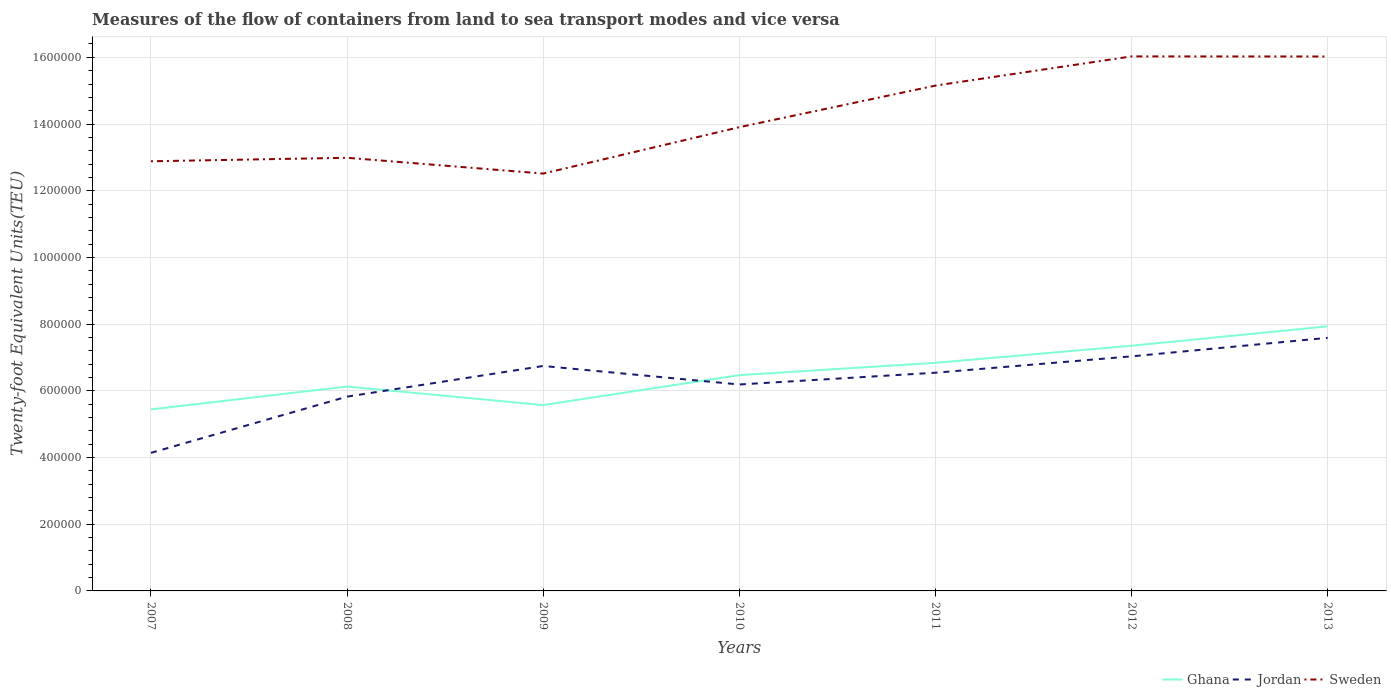Is the number of lines equal to the number of legend labels?
Provide a succinct answer. Yes. Across all years, what is the maximum container port traffic in Ghana?
Offer a very short reply. 5.44e+05. In which year was the container port traffic in Sweden maximum?
Provide a succinct answer. 2009. What is the total container port traffic in Jordan in the graph?
Your answer should be very brief. -4.91e+04. What is the difference between the highest and the second highest container port traffic in Ghana?
Make the answer very short. 2.49e+05. Is the container port traffic in Ghana strictly greater than the container port traffic in Jordan over the years?
Ensure brevity in your answer.  No. How many lines are there?
Give a very brief answer. 3. What is the difference between two consecutive major ticks on the Y-axis?
Your answer should be compact. 2.00e+05. Does the graph contain any zero values?
Offer a terse response. No. How are the legend labels stacked?
Ensure brevity in your answer.  Horizontal. What is the title of the graph?
Give a very brief answer. Measures of the flow of containers from land to sea transport modes and vice versa. Does "Isle of Man" appear as one of the legend labels in the graph?
Provide a short and direct response. No. What is the label or title of the Y-axis?
Ensure brevity in your answer.  Twenty-foot Equivalent Units(TEU). What is the Twenty-foot Equivalent Units(TEU) of Ghana in 2007?
Your answer should be compact. 5.44e+05. What is the Twenty-foot Equivalent Units(TEU) of Jordan in 2007?
Keep it short and to the point. 4.14e+05. What is the Twenty-foot Equivalent Units(TEU) of Sweden in 2007?
Make the answer very short. 1.29e+06. What is the Twenty-foot Equivalent Units(TEU) of Ghana in 2008?
Offer a very short reply. 6.13e+05. What is the Twenty-foot Equivalent Units(TEU) of Jordan in 2008?
Keep it short and to the point. 5.83e+05. What is the Twenty-foot Equivalent Units(TEU) in Sweden in 2008?
Your answer should be compact. 1.30e+06. What is the Twenty-foot Equivalent Units(TEU) of Ghana in 2009?
Provide a short and direct response. 5.57e+05. What is the Twenty-foot Equivalent Units(TEU) in Jordan in 2009?
Make the answer very short. 6.75e+05. What is the Twenty-foot Equivalent Units(TEU) in Sweden in 2009?
Your response must be concise. 1.25e+06. What is the Twenty-foot Equivalent Units(TEU) of Ghana in 2010?
Offer a very short reply. 6.47e+05. What is the Twenty-foot Equivalent Units(TEU) of Jordan in 2010?
Offer a very short reply. 6.19e+05. What is the Twenty-foot Equivalent Units(TEU) of Sweden in 2010?
Provide a succinct answer. 1.39e+06. What is the Twenty-foot Equivalent Units(TEU) in Ghana in 2011?
Offer a terse response. 6.84e+05. What is the Twenty-foot Equivalent Units(TEU) in Jordan in 2011?
Ensure brevity in your answer.  6.54e+05. What is the Twenty-foot Equivalent Units(TEU) in Sweden in 2011?
Offer a terse response. 1.52e+06. What is the Twenty-foot Equivalent Units(TEU) of Ghana in 2012?
Offer a very short reply. 7.35e+05. What is the Twenty-foot Equivalent Units(TEU) of Jordan in 2012?
Your answer should be compact. 7.03e+05. What is the Twenty-foot Equivalent Units(TEU) of Sweden in 2012?
Your answer should be compact. 1.60e+06. What is the Twenty-foot Equivalent Units(TEU) in Ghana in 2013?
Offer a very short reply. 7.93e+05. What is the Twenty-foot Equivalent Units(TEU) in Jordan in 2013?
Offer a terse response. 7.59e+05. What is the Twenty-foot Equivalent Units(TEU) of Sweden in 2013?
Offer a terse response. 1.60e+06. Across all years, what is the maximum Twenty-foot Equivalent Units(TEU) of Ghana?
Your response must be concise. 7.93e+05. Across all years, what is the maximum Twenty-foot Equivalent Units(TEU) in Jordan?
Your answer should be very brief. 7.59e+05. Across all years, what is the maximum Twenty-foot Equivalent Units(TEU) in Sweden?
Give a very brief answer. 1.60e+06. Across all years, what is the minimum Twenty-foot Equivalent Units(TEU) in Ghana?
Offer a terse response. 5.44e+05. Across all years, what is the minimum Twenty-foot Equivalent Units(TEU) of Jordan?
Offer a terse response. 4.14e+05. Across all years, what is the minimum Twenty-foot Equivalent Units(TEU) of Sweden?
Give a very brief answer. 1.25e+06. What is the total Twenty-foot Equivalent Units(TEU) in Ghana in the graph?
Provide a succinct answer. 4.57e+06. What is the total Twenty-foot Equivalent Units(TEU) in Jordan in the graph?
Keep it short and to the point. 4.41e+06. What is the total Twenty-foot Equivalent Units(TEU) of Sweden in the graph?
Offer a terse response. 9.95e+06. What is the difference between the Twenty-foot Equivalent Units(TEU) of Ghana in 2007 and that in 2008?
Your answer should be compact. -6.86e+04. What is the difference between the Twenty-foot Equivalent Units(TEU) of Jordan in 2007 and that in 2008?
Your answer should be very brief. -1.69e+05. What is the difference between the Twenty-foot Equivalent Units(TEU) of Sweden in 2007 and that in 2008?
Ensure brevity in your answer.  -1.05e+04. What is the difference between the Twenty-foot Equivalent Units(TEU) in Ghana in 2007 and that in 2009?
Keep it short and to the point. -1.30e+04. What is the difference between the Twenty-foot Equivalent Units(TEU) in Jordan in 2007 and that in 2009?
Offer a very short reply. -2.61e+05. What is the difference between the Twenty-foot Equivalent Units(TEU) of Sweden in 2007 and that in 2009?
Offer a terse response. 3.69e+04. What is the difference between the Twenty-foot Equivalent Units(TEU) of Ghana in 2007 and that in 2010?
Your response must be concise. -1.03e+05. What is the difference between the Twenty-foot Equivalent Units(TEU) in Jordan in 2007 and that in 2010?
Keep it short and to the point. -2.05e+05. What is the difference between the Twenty-foot Equivalent Units(TEU) of Sweden in 2007 and that in 2010?
Offer a terse response. -1.02e+05. What is the difference between the Twenty-foot Equivalent Units(TEU) in Ghana in 2007 and that in 2011?
Give a very brief answer. -1.40e+05. What is the difference between the Twenty-foot Equivalent Units(TEU) of Jordan in 2007 and that in 2011?
Make the answer very short. -2.40e+05. What is the difference between the Twenty-foot Equivalent Units(TEU) in Sweden in 2007 and that in 2011?
Provide a short and direct response. -2.27e+05. What is the difference between the Twenty-foot Equivalent Units(TEU) of Ghana in 2007 and that in 2012?
Provide a short and direct response. -1.91e+05. What is the difference between the Twenty-foot Equivalent Units(TEU) of Jordan in 2007 and that in 2012?
Ensure brevity in your answer.  -2.89e+05. What is the difference between the Twenty-foot Equivalent Units(TEU) of Sweden in 2007 and that in 2012?
Ensure brevity in your answer.  -3.14e+05. What is the difference between the Twenty-foot Equivalent Units(TEU) in Ghana in 2007 and that in 2013?
Provide a succinct answer. -2.49e+05. What is the difference between the Twenty-foot Equivalent Units(TEU) in Jordan in 2007 and that in 2013?
Provide a short and direct response. -3.45e+05. What is the difference between the Twenty-foot Equivalent Units(TEU) of Sweden in 2007 and that in 2013?
Your answer should be very brief. -3.14e+05. What is the difference between the Twenty-foot Equivalent Units(TEU) in Ghana in 2008 and that in 2009?
Your answer should be very brief. 5.55e+04. What is the difference between the Twenty-foot Equivalent Units(TEU) in Jordan in 2008 and that in 2009?
Ensure brevity in your answer.  -9.20e+04. What is the difference between the Twenty-foot Equivalent Units(TEU) in Sweden in 2008 and that in 2009?
Your answer should be very brief. 4.74e+04. What is the difference between the Twenty-foot Equivalent Units(TEU) of Ghana in 2008 and that in 2010?
Offer a terse response. -3.42e+04. What is the difference between the Twenty-foot Equivalent Units(TEU) in Jordan in 2008 and that in 2010?
Your answer should be compact. -3.65e+04. What is the difference between the Twenty-foot Equivalent Units(TEU) in Sweden in 2008 and that in 2010?
Ensure brevity in your answer.  -9.17e+04. What is the difference between the Twenty-foot Equivalent Units(TEU) in Ghana in 2008 and that in 2011?
Offer a terse response. -7.11e+04. What is the difference between the Twenty-foot Equivalent Units(TEU) of Jordan in 2008 and that in 2011?
Your answer should be compact. -7.18e+04. What is the difference between the Twenty-foot Equivalent Units(TEU) of Sweden in 2008 and that in 2011?
Offer a very short reply. -2.16e+05. What is the difference between the Twenty-foot Equivalent Units(TEU) of Ghana in 2008 and that in 2012?
Your answer should be compact. -1.22e+05. What is the difference between the Twenty-foot Equivalent Units(TEU) in Jordan in 2008 and that in 2012?
Keep it short and to the point. -1.21e+05. What is the difference between the Twenty-foot Equivalent Units(TEU) of Sweden in 2008 and that in 2012?
Give a very brief answer. -3.04e+05. What is the difference between the Twenty-foot Equivalent Units(TEU) in Ghana in 2008 and that in 2013?
Keep it short and to the point. -1.80e+05. What is the difference between the Twenty-foot Equivalent Units(TEU) in Jordan in 2008 and that in 2013?
Keep it short and to the point. -1.76e+05. What is the difference between the Twenty-foot Equivalent Units(TEU) of Sweden in 2008 and that in 2013?
Offer a very short reply. -3.04e+05. What is the difference between the Twenty-foot Equivalent Units(TEU) of Ghana in 2009 and that in 2010?
Offer a very short reply. -8.97e+04. What is the difference between the Twenty-foot Equivalent Units(TEU) of Jordan in 2009 and that in 2010?
Offer a terse response. 5.55e+04. What is the difference between the Twenty-foot Equivalent Units(TEU) of Sweden in 2009 and that in 2010?
Your answer should be compact. -1.39e+05. What is the difference between the Twenty-foot Equivalent Units(TEU) in Ghana in 2009 and that in 2011?
Provide a succinct answer. -1.27e+05. What is the difference between the Twenty-foot Equivalent Units(TEU) of Jordan in 2009 and that in 2011?
Your answer should be compact. 2.02e+04. What is the difference between the Twenty-foot Equivalent Units(TEU) of Sweden in 2009 and that in 2011?
Provide a succinct answer. -2.64e+05. What is the difference between the Twenty-foot Equivalent Units(TEU) of Ghana in 2009 and that in 2012?
Ensure brevity in your answer.  -1.78e+05. What is the difference between the Twenty-foot Equivalent Units(TEU) of Jordan in 2009 and that in 2012?
Offer a terse response. -2.88e+04. What is the difference between the Twenty-foot Equivalent Units(TEU) in Sweden in 2009 and that in 2012?
Offer a very short reply. -3.51e+05. What is the difference between the Twenty-foot Equivalent Units(TEU) of Ghana in 2009 and that in 2013?
Make the answer very short. -2.36e+05. What is the difference between the Twenty-foot Equivalent Units(TEU) in Jordan in 2009 and that in 2013?
Make the answer very short. -8.44e+04. What is the difference between the Twenty-foot Equivalent Units(TEU) in Sweden in 2009 and that in 2013?
Your response must be concise. -3.51e+05. What is the difference between the Twenty-foot Equivalent Units(TEU) of Ghana in 2010 and that in 2011?
Offer a terse response. -3.69e+04. What is the difference between the Twenty-foot Equivalent Units(TEU) in Jordan in 2010 and that in 2011?
Your answer should be very brief. -3.53e+04. What is the difference between the Twenty-foot Equivalent Units(TEU) of Sweden in 2010 and that in 2011?
Your answer should be very brief. -1.25e+05. What is the difference between the Twenty-foot Equivalent Units(TEU) in Ghana in 2010 and that in 2012?
Keep it short and to the point. -8.82e+04. What is the difference between the Twenty-foot Equivalent Units(TEU) in Jordan in 2010 and that in 2012?
Provide a succinct answer. -8.44e+04. What is the difference between the Twenty-foot Equivalent Units(TEU) in Sweden in 2010 and that in 2012?
Your answer should be very brief. -2.12e+05. What is the difference between the Twenty-foot Equivalent Units(TEU) in Ghana in 2010 and that in 2013?
Your response must be concise. -1.46e+05. What is the difference between the Twenty-foot Equivalent Units(TEU) of Jordan in 2010 and that in 2013?
Provide a succinct answer. -1.40e+05. What is the difference between the Twenty-foot Equivalent Units(TEU) of Sweden in 2010 and that in 2013?
Offer a terse response. -2.12e+05. What is the difference between the Twenty-foot Equivalent Units(TEU) in Ghana in 2011 and that in 2012?
Keep it short and to the point. -5.13e+04. What is the difference between the Twenty-foot Equivalent Units(TEU) in Jordan in 2011 and that in 2012?
Your answer should be very brief. -4.91e+04. What is the difference between the Twenty-foot Equivalent Units(TEU) of Sweden in 2011 and that in 2012?
Make the answer very short. -8.76e+04. What is the difference between the Twenty-foot Equivalent Units(TEU) in Ghana in 2011 and that in 2013?
Ensure brevity in your answer.  -1.09e+05. What is the difference between the Twenty-foot Equivalent Units(TEU) of Jordan in 2011 and that in 2013?
Offer a very short reply. -1.05e+05. What is the difference between the Twenty-foot Equivalent Units(TEU) in Sweden in 2011 and that in 2013?
Keep it short and to the point. -8.73e+04. What is the difference between the Twenty-foot Equivalent Units(TEU) of Ghana in 2012 and that in 2013?
Give a very brief answer. -5.81e+04. What is the difference between the Twenty-foot Equivalent Units(TEU) in Jordan in 2012 and that in 2013?
Your answer should be compact. -5.56e+04. What is the difference between the Twenty-foot Equivalent Units(TEU) of Sweden in 2012 and that in 2013?
Offer a very short reply. 302.98. What is the difference between the Twenty-foot Equivalent Units(TEU) in Ghana in 2007 and the Twenty-foot Equivalent Units(TEU) in Jordan in 2008?
Your answer should be compact. -3.82e+04. What is the difference between the Twenty-foot Equivalent Units(TEU) in Ghana in 2007 and the Twenty-foot Equivalent Units(TEU) in Sweden in 2008?
Offer a very short reply. -7.54e+05. What is the difference between the Twenty-foot Equivalent Units(TEU) in Jordan in 2007 and the Twenty-foot Equivalent Units(TEU) in Sweden in 2008?
Ensure brevity in your answer.  -8.85e+05. What is the difference between the Twenty-foot Equivalent Units(TEU) in Ghana in 2007 and the Twenty-foot Equivalent Units(TEU) in Jordan in 2009?
Make the answer very short. -1.30e+05. What is the difference between the Twenty-foot Equivalent Units(TEU) in Ghana in 2007 and the Twenty-foot Equivalent Units(TEU) in Sweden in 2009?
Offer a terse response. -7.07e+05. What is the difference between the Twenty-foot Equivalent Units(TEU) of Jordan in 2007 and the Twenty-foot Equivalent Units(TEU) of Sweden in 2009?
Offer a very short reply. -8.37e+05. What is the difference between the Twenty-foot Equivalent Units(TEU) in Ghana in 2007 and the Twenty-foot Equivalent Units(TEU) in Jordan in 2010?
Give a very brief answer. -7.47e+04. What is the difference between the Twenty-foot Equivalent Units(TEU) in Ghana in 2007 and the Twenty-foot Equivalent Units(TEU) in Sweden in 2010?
Your answer should be very brief. -8.46e+05. What is the difference between the Twenty-foot Equivalent Units(TEU) in Jordan in 2007 and the Twenty-foot Equivalent Units(TEU) in Sweden in 2010?
Your answer should be compact. -9.77e+05. What is the difference between the Twenty-foot Equivalent Units(TEU) in Ghana in 2007 and the Twenty-foot Equivalent Units(TEU) in Jordan in 2011?
Ensure brevity in your answer.  -1.10e+05. What is the difference between the Twenty-foot Equivalent Units(TEU) in Ghana in 2007 and the Twenty-foot Equivalent Units(TEU) in Sweden in 2011?
Offer a terse response. -9.71e+05. What is the difference between the Twenty-foot Equivalent Units(TEU) of Jordan in 2007 and the Twenty-foot Equivalent Units(TEU) of Sweden in 2011?
Your answer should be very brief. -1.10e+06. What is the difference between the Twenty-foot Equivalent Units(TEU) of Ghana in 2007 and the Twenty-foot Equivalent Units(TEU) of Jordan in 2012?
Your answer should be compact. -1.59e+05. What is the difference between the Twenty-foot Equivalent Units(TEU) of Ghana in 2007 and the Twenty-foot Equivalent Units(TEU) of Sweden in 2012?
Your answer should be very brief. -1.06e+06. What is the difference between the Twenty-foot Equivalent Units(TEU) of Jordan in 2007 and the Twenty-foot Equivalent Units(TEU) of Sweden in 2012?
Provide a succinct answer. -1.19e+06. What is the difference between the Twenty-foot Equivalent Units(TEU) in Ghana in 2007 and the Twenty-foot Equivalent Units(TEU) in Jordan in 2013?
Keep it short and to the point. -2.15e+05. What is the difference between the Twenty-foot Equivalent Units(TEU) in Ghana in 2007 and the Twenty-foot Equivalent Units(TEU) in Sweden in 2013?
Provide a short and direct response. -1.06e+06. What is the difference between the Twenty-foot Equivalent Units(TEU) of Jordan in 2007 and the Twenty-foot Equivalent Units(TEU) of Sweden in 2013?
Offer a very short reply. -1.19e+06. What is the difference between the Twenty-foot Equivalent Units(TEU) in Ghana in 2008 and the Twenty-foot Equivalent Units(TEU) in Jordan in 2009?
Make the answer very short. -6.17e+04. What is the difference between the Twenty-foot Equivalent Units(TEU) in Ghana in 2008 and the Twenty-foot Equivalent Units(TEU) in Sweden in 2009?
Offer a terse response. -6.39e+05. What is the difference between the Twenty-foot Equivalent Units(TEU) of Jordan in 2008 and the Twenty-foot Equivalent Units(TEU) of Sweden in 2009?
Offer a terse response. -6.69e+05. What is the difference between the Twenty-foot Equivalent Units(TEU) of Ghana in 2008 and the Twenty-foot Equivalent Units(TEU) of Jordan in 2010?
Ensure brevity in your answer.  -6152.83. What is the difference between the Twenty-foot Equivalent Units(TEU) in Ghana in 2008 and the Twenty-foot Equivalent Units(TEU) in Sweden in 2010?
Offer a terse response. -7.78e+05. What is the difference between the Twenty-foot Equivalent Units(TEU) of Jordan in 2008 and the Twenty-foot Equivalent Units(TEU) of Sweden in 2010?
Ensure brevity in your answer.  -8.08e+05. What is the difference between the Twenty-foot Equivalent Units(TEU) of Ghana in 2008 and the Twenty-foot Equivalent Units(TEU) of Jordan in 2011?
Your answer should be compact. -4.14e+04. What is the difference between the Twenty-foot Equivalent Units(TEU) of Ghana in 2008 and the Twenty-foot Equivalent Units(TEU) of Sweden in 2011?
Provide a succinct answer. -9.02e+05. What is the difference between the Twenty-foot Equivalent Units(TEU) in Jordan in 2008 and the Twenty-foot Equivalent Units(TEU) in Sweden in 2011?
Ensure brevity in your answer.  -9.33e+05. What is the difference between the Twenty-foot Equivalent Units(TEU) in Ghana in 2008 and the Twenty-foot Equivalent Units(TEU) in Jordan in 2012?
Your response must be concise. -9.05e+04. What is the difference between the Twenty-foot Equivalent Units(TEU) in Ghana in 2008 and the Twenty-foot Equivalent Units(TEU) in Sweden in 2012?
Provide a succinct answer. -9.90e+05. What is the difference between the Twenty-foot Equivalent Units(TEU) in Jordan in 2008 and the Twenty-foot Equivalent Units(TEU) in Sweden in 2012?
Offer a very short reply. -1.02e+06. What is the difference between the Twenty-foot Equivalent Units(TEU) in Ghana in 2008 and the Twenty-foot Equivalent Units(TEU) in Jordan in 2013?
Give a very brief answer. -1.46e+05. What is the difference between the Twenty-foot Equivalent Units(TEU) in Ghana in 2008 and the Twenty-foot Equivalent Units(TEU) in Sweden in 2013?
Make the answer very short. -9.90e+05. What is the difference between the Twenty-foot Equivalent Units(TEU) of Jordan in 2008 and the Twenty-foot Equivalent Units(TEU) of Sweden in 2013?
Give a very brief answer. -1.02e+06. What is the difference between the Twenty-foot Equivalent Units(TEU) of Ghana in 2009 and the Twenty-foot Equivalent Units(TEU) of Jordan in 2010?
Give a very brief answer. -6.17e+04. What is the difference between the Twenty-foot Equivalent Units(TEU) of Ghana in 2009 and the Twenty-foot Equivalent Units(TEU) of Sweden in 2010?
Give a very brief answer. -8.33e+05. What is the difference between the Twenty-foot Equivalent Units(TEU) in Jordan in 2009 and the Twenty-foot Equivalent Units(TEU) in Sweden in 2010?
Provide a succinct answer. -7.16e+05. What is the difference between the Twenty-foot Equivalent Units(TEU) in Ghana in 2009 and the Twenty-foot Equivalent Units(TEU) in Jordan in 2011?
Provide a short and direct response. -9.70e+04. What is the difference between the Twenty-foot Equivalent Units(TEU) of Ghana in 2009 and the Twenty-foot Equivalent Units(TEU) of Sweden in 2011?
Provide a succinct answer. -9.58e+05. What is the difference between the Twenty-foot Equivalent Units(TEU) of Jordan in 2009 and the Twenty-foot Equivalent Units(TEU) of Sweden in 2011?
Ensure brevity in your answer.  -8.41e+05. What is the difference between the Twenty-foot Equivalent Units(TEU) of Ghana in 2009 and the Twenty-foot Equivalent Units(TEU) of Jordan in 2012?
Give a very brief answer. -1.46e+05. What is the difference between the Twenty-foot Equivalent Units(TEU) in Ghana in 2009 and the Twenty-foot Equivalent Units(TEU) in Sweden in 2012?
Provide a short and direct response. -1.05e+06. What is the difference between the Twenty-foot Equivalent Units(TEU) of Jordan in 2009 and the Twenty-foot Equivalent Units(TEU) of Sweden in 2012?
Offer a very short reply. -9.28e+05. What is the difference between the Twenty-foot Equivalent Units(TEU) in Ghana in 2009 and the Twenty-foot Equivalent Units(TEU) in Jordan in 2013?
Offer a very short reply. -2.02e+05. What is the difference between the Twenty-foot Equivalent Units(TEU) in Ghana in 2009 and the Twenty-foot Equivalent Units(TEU) in Sweden in 2013?
Provide a succinct answer. -1.05e+06. What is the difference between the Twenty-foot Equivalent Units(TEU) in Jordan in 2009 and the Twenty-foot Equivalent Units(TEU) in Sweden in 2013?
Make the answer very short. -9.28e+05. What is the difference between the Twenty-foot Equivalent Units(TEU) of Ghana in 2010 and the Twenty-foot Equivalent Units(TEU) of Jordan in 2011?
Keep it short and to the point. -7230.74. What is the difference between the Twenty-foot Equivalent Units(TEU) of Ghana in 2010 and the Twenty-foot Equivalent Units(TEU) of Sweden in 2011?
Your answer should be compact. -8.68e+05. What is the difference between the Twenty-foot Equivalent Units(TEU) of Jordan in 2010 and the Twenty-foot Equivalent Units(TEU) of Sweden in 2011?
Provide a short and direct response. -8.96e+05. What is the difference between the Twenty-foot Equivalent Units(TEU) in Ghana in 2010 and the Twenty-foot Equivalent Units(TEU) in Jordan in 2012?
Provide a short and direct response. -5.63e+04. What is the difference between the Twenty-foot Equivalent Units(TEU) of Ghana in 2010 and the Twenty-foot Equivalent Units(TEU) of Sweden in 2012?
Keep it short and to the point. -9.56e+05. What is the difference between the Twenty-foot Equivalent Units(TEU) in Jordan in 2010 and the Twenty-foot Equivalent Units(TEU) in Sweden in 2012?
Make the answer very short. -9.84e+05. What is the difference between the Twenty-foot Equivalent Units(TEU) of Ghana in 2010 and the Twenty-foot Equivalent Units(TEU) of Jordan in 2013?
Provide a succinct answer. -1.12e+05. What is the difference between the Twenty-foot Equivalent Units(TEU) of Ghana in 2010 and the Twenty-foot Equivalent Units(TEU) of Sweden in 2013?
Keep it short and to the point. -9.55e+05. What is the difference between the Twenty-foot Equivalent Units(TEU) in Jordan in 2010 and the Twenty-foot Equivalent Units(TEU) in Sweden in 2013?
Offer a terse response. -9.83e+05. What is the difference between the Twenty-foot Equivalent Units(TEU) in Ghana in 2011 and the Twenty-foot Equivalent Units(TEU) in Jordan in 2012?
Give a very brief answer. -1.94e+04. What is the difference between the Twenty-foot Equivalent Units(TEU) in Ghana in 2011 and the Twenty-foot Equivalent Units(TEU) in Sweden in 2012?
Provide a short and direct response. -9.19e+05. What is the difference between the Twenty-foot Equivalent Units(TEU) of Jordan in 2011 and the Twenty-foot Equivalent Units(TEU) of Sweden in 2012?
Offer a very short reply. -9.48e+05. What is the difference between the Twenty-foot Equivalent Units(TEU) of Ghana in 2011 and the Twenty-foot Equivalent Units(TEU) of Jordan in 2013?
Make the answer very short. -7.50e+04. What is the difference between the Twenty-foot Equivalent Units(TEU) in Ghana in 2011 and the Twenty-foot Equivalent Units(TEU) in Sweden in 2013?
Provide a short and direct response. -9.19e+05. What is the difference between the Twenty-foot Equivalent Units(TEU) of Jordan in 2011 and the Twenty-foot Equivalent Units(TEU) of Sweden in 2013?
Keep it short and to the point. -9.48e+05. What is the difference between the Twenty-foot Equivalent Units(TEU) of Ghana in 2012 and the Twenty-foot Equivalent Units(TEU) of Jordan in 2013?
Keep it short and to the point. -2.37e+04. What is the difference between the Twenty-foot Equivalent Units(TEU) in Ghana in 2012 and the Twenty-foot Equivalent Units(TEU) in Sweden in 2013?
Provide a short and direct response. -8.67e+05. What is the difference between the Twenty-foot Equivalent Units(TEU) in Jordan in 2012 and the Twenty-foot Equivalent Units(TEU) in Sweden in 2013?
Make the answer very short. -8.99e+05. What is the average Twenty-foot Equivalent Units(TEU) in Ghana per year?
Your response must be concise. 6.53e+05. What is the average Twenty-foot Equivalent Units(TEU) in Jordan per year?
Your answer should be very brief. 6.30e+05. What is the average Twenty-foot Equivalent Units(TEU) of Sweden per year?
Provide a succinct answer. 1.42e+06. In the year 2007, what is the difference between the Twenty-foot Equivalent Units(TEU) in Ghana and Twenty-foot Equivalent Units(TEU) in Jordan?
Keep it short and to the point. 1.30e+05. In the year 2007, what is the difference between the Twenty-foot Equivalent Units(TEU) of Ghana and Twenty-foot Equivalent Units(TEU) of Sweden?
Your response must be concise. -7.44e+05. In the year 2007, what is the difference between the Twenty-foot Equivalent Units(TEU) in Jordan and Twenty-foot Equivalent Units(TEU) in Sweden?
Ensure brevity in your answer.  -8.74e+05. In the year 2008, what is the difference between the Twenty-foot Equivalent Units(TEU) in Ghana and Twenty-foot Equivalent Units(TEU) in Jordan?
Your answer should be compact. 3.03e+04. In the year 2008, what is the difference between the Twenty-foot Equivalent Units(TEU) in Ghana and Twenty-foot Equivalent Units(TEU) in Sweden?
Provide a succinct answer. -6.86e+05. In the year 2008, what is the difference between the Twenty-foot Equivalent Units(TEU) in Jordan and Twenty-foot Equivalent Units(TEU) in Sweden?
Your response must be concise. -7.16e+05. In the year 2009, what is the difference between the Twenty-foot Equivalent Units(TEU) in Ghana and Twenty-foot Equivalent Units(TEU) in Jordan?
Make the answer very short. -1.17e+05. In the year 2009, what is the difference between the Twenty-foot Equivalent Units(TEU) of Ghana and Twenty-foot Equivalent Units(TEU) of Sweden?
Offer a terse response. -6.94e+05. In the year 2009, what is the difference between the Twenty-foot Equivalent Units(TEU) of Jordan and Twenty-foot Equivalent Units(TEU) of Sweden?
Ensure brevity in your answer.  -5.77e+05. In the year 2010, what is the difference between the Twenty-foot Equivalent Units(TEU) of Ghana and Twenty-foot Equivalent Units(TEU) of Jordan?
Make the answer very short. 2.81e+04. In the year 2010, what is the difference between the Twenty-foot Equivalent Units(TEU) in Ghana and Twenty-foot Equivalent Units(TEU) in Sweden?
Provide a short and direct response. -7.43e+05. In the year 2010, what is the difference between the Twenty-foot Equivalent Units(TEU) in Jordan and Twenty-foot Equivalent Units(TEU) in Sweden?
Make the answer very short. -7.72e+05. In the year 2011, what is the difference between the Twenty-foot Equivalent Units(TEU) in Ghana and Twenty-foot Equivalent Units(TEU) in Jordan?
Provide a succinct answer. 2.97e+04. In the year 2011, what is the difference between the Twenty-foot Equivalent Units(TEU) in Ghana and Twenty-foot Equivalent Units(TEU) in Sweden?
Make the answer very short. -8.31e+05. In the year 2011, what is the difference between the Twenty-foot Equivalent Units(TEU) in Jordan and Twenty-foot Equivalent Units(TEU) in Sweden?
Ensure brevity in your answer.  -8.61e+05. In the year 2012, what is the difference between the Twenty-foot Equivalent Units(TEU) of Ghana and Twenty-foot Equivalent Units(TEU) of Jordan?
Give a very brief answer. 3.19e+04. In the year 2012, what is the difference between the Twenty-foot Equivalent Units(TEU) of Ghana and Twenty-foot Equivalent Units(TEU) of Sweden?
Keep it short and to the point. -8.68e+05. In the year 2012, what is the difference between the Twenty-foot Equivalent Units(TEU) in Jordan and Twenty-foot Equivalent Units(TEU) in Sweden?
Ensure brevity in your answer.  -8.99e+05. In the year 2013, what is the difference between the Twenty-foot Equivalent Units(TEU) of Ghana and Twenty-foot Equivalent Units(TEU) of Jordan?
Your response must be concise. 3.44e+04. In the year 2013, what is the difference between the Twenty-foot Equivalent Units(TEU) of Ghana and Twenty-foot Equivalent Units(TEU) of Sweden?
Provide a short and direct response. -8.09e+05. In the year 2013, what is the difference between the Twenty-foot Equivalent Units(TEU) of Jordan and Twenty-foot Equivalent Units(TEU) of Sweden?
Make the answer very short. -8.44e+05. What is the ratio of the Twenty-foot Equivalent Units(TEU) of Ghana in 2007 to that in 2008?
Your answer should be very brief. 0.89. What is the ratio of the Twenty-foot Equivalent Units(TEU) in Jordan in 2007 to that in 2008?
Keep it short and to the point. 0.71. What is the ratio of the Twenty-foot Equivalent Units(TEU) in Sweden in 2007 to that in 2008?
Make the answer very short. 0.99. What is the ratio of the Twenty-foot Equivalent Units(TEU) of Ghana in 2007 to that in 2009?
Provide a succinct answer. 0.98. What is the ratio of the Twenty-foot Equivalent Units(TEU) in Jordan in 2007 to that in 2009?
Ensure brevity in your answer.  0.61. What is the ratio of the Twenty-foot Equivalent Units(TEU) in Sweden in 2007 to that in 2009?
Provide a succinct answer. 1.03. What is the ratio of the Twenty-foot Equivalent Units(TEU) in Ghana in 2007 to that in 2010?
Give a very brief answer. 0.84. What is the ratio of the Twenty-foot Equivalent Units(TEU) in Jordan in 2007 to that in 2010?
Your answer should be very brief. 0.67. What is the ratio of the Twenty-foot Equivalent Units(TEU) in Sweden in 2007 to that in 2010?
Offer a very short reply. 0.93. What is the ratio of the Twenty-foot Equivalent Units(TEU) in Ghana in 2007 to that in 2011?
Provide a short and direct response. 0.8. What is the ratio of the Twenty-foot Equivalent Units(TEU) in Jordan in 2007 to that in 2011?
Your response must be concise. 0.63. What is the ratio of the Twenty-foot Equivalent Units(TEU) in Sweden in 2007 to that in 2011?
Your response must be concise. 0.85. What is the ratio of the Twenty-foot Equivalent Units(TEU) in Ghana in 2007 to that in 2012?
Provide a short and direct response. 0.74. What is the ratio of the Twenty-foot Equivalent Units(TEU) of Jordan in 2007 to that in 2012?
Your answer should be compact. 0.59. What is the ratio of the Twenty-foot Equivalent Units(TEU) of Sweden in 2007 to that in 2012?
Provide a succinct answer. 0.8. What is the ratio of the Twenty-foot Equivalent Units(TEU) of Ghana in 2007 to that in 2013?
Your answer should be compact. 0.69. What is the ratio of the Twenty-foot Equivalent Units(TEU) in Jordan in 2007 to that in 2013?
Provide a short and direct response. 0.55. What is the ratio of the Twenty-foot Equivalent Units(TEU) of Sweden in 2007 to that in 2013?
Offer a very short reply. 0.8. What is the ratio of the Twenty-foot Equivalent Units(TEU) in Ghana in 2008 to that in 2009?
Keep it short and to the point. 1.1. What is the ratio of the Twenty-foot Equivalent Units(TEU) of Jordan in 2008 to that in 2009?
Provide a short and direct response. 0.86. What is the ratio of the Twenty-foot Equivalent Units(TEU) of Sweden in 2008 to that in 2009?
Provide a short and direct response. 1.04. What is the ratio of the Twenty-foot Equivalent Units(TEU) of Ghana in 2008 to that in 2010?
Your response must be concise. 0.95. What is the ratio of the Twenty-foot Equivalent Units(TEU) of Jordan in 2008 to that in 2010?
Your response must be concise. 0.94. What is the ratio of the Twenty-foot Equivalent Units(TEU) in Sweden in 2008 to that in 2010?
Offer a terse response. 0.93. What is the ratio of the Twenty-foot Equivalent Units(TEU) of Ghana in 2008 to that in 2011?
Ensure brevity in your answer.  0.9. What is the ratio of the Twenty-foot Equivalent Units(TEU) in Jordan in 2008 to that in 2011?
Offer a very short reply. 0.89. What is the ratio of the Twenty-foot Equivalent Units(TEU) of Sweden in 2008 to that in 2011?
Ensure brevity in your answer.  0.86. What is the ratio of the Twenty-foot Equivalent Units(TEU) of Ghana in 2008 to that in 2012?
Keep it short and to the point. 0.83. What is the ratio of the Twenty-foot Equivalent Units(TEU) in Jordan in 2008 to that in 2012?
Make the answer very short. 0.83. What is the ratio of the Twenty-foot Equivalent Units(TEU) in Sweden in 2008 to that in 2012?
Give a very brief answer. 0.81. What is the ratio of the Twenty-foot Equivalent Units(TEU) in Ghana in 2008 to that in 2013?
Provide a succinct answer. 0.77. What is the ratio of the Twenty-foot Equivalent Units(TEU) in Jordan in 2008 to that in 2013?
Provide a succinct answer. 0.77. What is the ratio of the Twenty-foot Equivalent Units(TEU) of Sweden in 2008 to that in 2013?
Give a very brief answer. 0.81. What is the ratio of the Twenty-foot Equivalent Units(TEU) in Ghana in 2009 to that in 2010?
Ensure brevity in your answer.  0.86. What is the ratio of the Twenty-foot Equivalent Units(TEU) in Jordan in 2009 to that in 2010?
Your answer should be very brief. 1.09. What is the ratio of the Twenty-foot Equivalent Units(TEU) in Ghana in 2009 to that in 2011?
Your response must be concise. 0.81. What is the ratio of the Twenty-foot Equivalent Units(TEU) in Jordan in 2009 to that in 2011?
Your response must be concise. 1.03. What is the ratio of the Twenty-foot Equivalent Units(TEU) in Sweden in 2009 to that in 2011?
Make the answer very short. 0.83. What is the ratio of the Twenty-foot Equivalent Units(TEU) in Ghana in 2009 to that in 2012?
Make the answer very short. 0.76. What is the ratio of the Twenty-foot Equivalent Units(TEU) in Jordan in 2009 to that in 2012?
Offer a very short reply. 0.96. What is the ratio of the Twenty-foot Equivalent Units(TEU) of Sweden in 2009 to that in 2012?
Your response must be concise. 0.78. What is the ratio of the Twenty-foot Equivalent Units(TEU) in Ghana in 2009 to that in 2013?
Make the answer very short. 0.7. What is the ratio of the Twenty-foot Equivalent Units(TEU) of Jordan in 2009 to that in 2013?
Provide a short and direct response. 0.89. What is the ratio of the Twenty-foot Equivalent Units(TEU) in Sweden in 2009 to that in 2013?
Your response must be concise. 0.78. What is the ratio of the Twenty-foot Equivalent Units(TEU) in Ghana in 2010 to that in 2011?
Give a very brief answer. 0.95. What is the ratio of the Twenty-foot Equivalent Units(TEU) of Jordan in 2010 to that in 2011?
Your answer should be compact. 0.95. What is the ratio of the Twenty-foot Equivalent Units(TEU) in Sweden in 2010 to that in 2011?
Your answer should be compact. 0.92. What is the ratio of the Twenty-foot Equivalent Units(TEU) in Ghana in 2010 to that in 2012?
Your answer should be very brief. 0.88. What is the ratio of the Twenty-foot Equivalent Units(TEU) of Jordan in 2010 to that in 2012?
Ensure brevity in your answer.  0.88. What is the ratio of the Twenty-foot Equivalent Units(TEU) in Sweden in 2010 to that in 2012?
Your answer should be compact. 0.87. What is the ratio of the Twenty-foot Equivalent Units(TEU) of Ghana in 2010 to that in 2013?
Provide a succinct answer. 0.82. What is the ratio of the Twenty-foot Equivalent Units(TEU) of Jordan in 2010 to that in 2013?
Your response must be concise. 0.82. What is the ratio of the Twenty-foot Equivalent Units(TEU) of Sweden in 2010 to that in 2013?
Your response must be concise. 0.87. What is the ratio of the Twenty-foot Equivalent Units(TEU) in Ghana in 2011 to that in 2012?
Ensure brevity in your answer.  0.93. What is the ratio of the Twenty-foot Equivalent Units(TEU) in Jordan in 2011 to that in 2012?
Offer a terse response. 0.93. What is the ratio of the Twenty-foot Equivalent Units(TEU) in Sweden in 2011 to that in 2012?
Provide a short and direct response. 0.95. What is the ratio of the Twenty-foot Equivalent Units(TEU) in Ghana in 2011 to that in 2013?
Your answer should be very brief. 0.86. What is the ratio of the Twenty-foot Equivalent Units(TEU) in Jordan in 2011 to that in 2013?
Make the answer very short. 0.86. What is the ratio of the Twenty-foot Equivalent Units(TEU) of Sweden in 2011 to that in 2013?
Make the answer very short. 0.95. What is the ratio of the Twenty-foot Equivalent Units(TEU) in Ghana in 2012 to that in 2013?
Offer a terse response. 0.93. What is the ratio of the Twenty-foot Equivalent Units(TEU) of Jordan in 2012 to that in 2013?
Your response must be concise. 0.93. What is the ratio of the Twenty-foot Equivalent Units(TEU) of Sweden in 2012 to that in 2013?
Offer a terse response. 1. What is the difference between the highest and the second highest Twenty-foot Equivalent Units(TEU) of Ghana?
Provide a short and direct response. 5.81e+04. What is the difference between the highest and the second highest Twenty-foot Equivalent Units(TEU) of Jordan?
Offer a terse response. 5.56e+04. What is the difference between the highest and the second highest Twenty-foot Equivalent Units(TEU) in Sweden?
Offer a very short reply. 302.98. What is the difference between the highest and the lowest Twenty-foot Equivalent Units(TEU) of Ghana?
Offer a terse response. 2.49e+05. What is the difference between the highest and the lowest Twenty-foot Equivalent Units(TEU) in Jordan?
Give a very brief answer. 3.45e+05. What is the difference between the highest and the lowest Twenty-foot Equivalent Units(TEU) of Sweden?
Your answer should be very brief. 3.51e+05. 